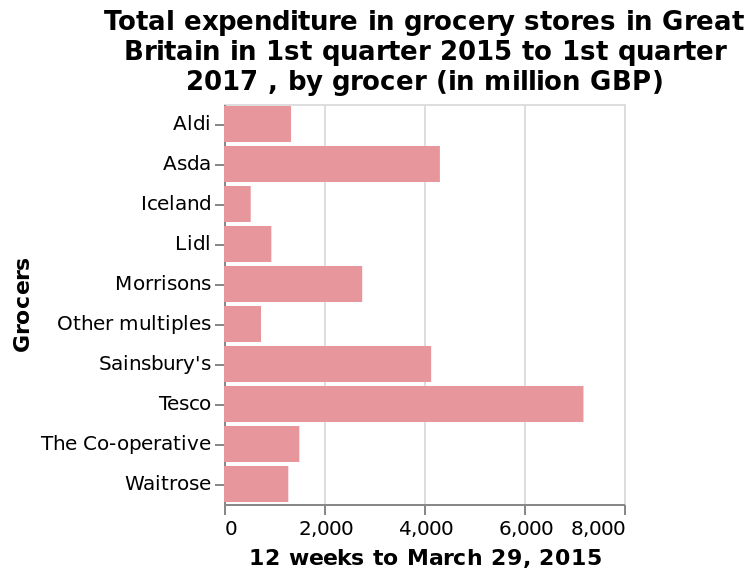<image>
Which grocery stores had similar expenditure? Sainsburys and Asda. 